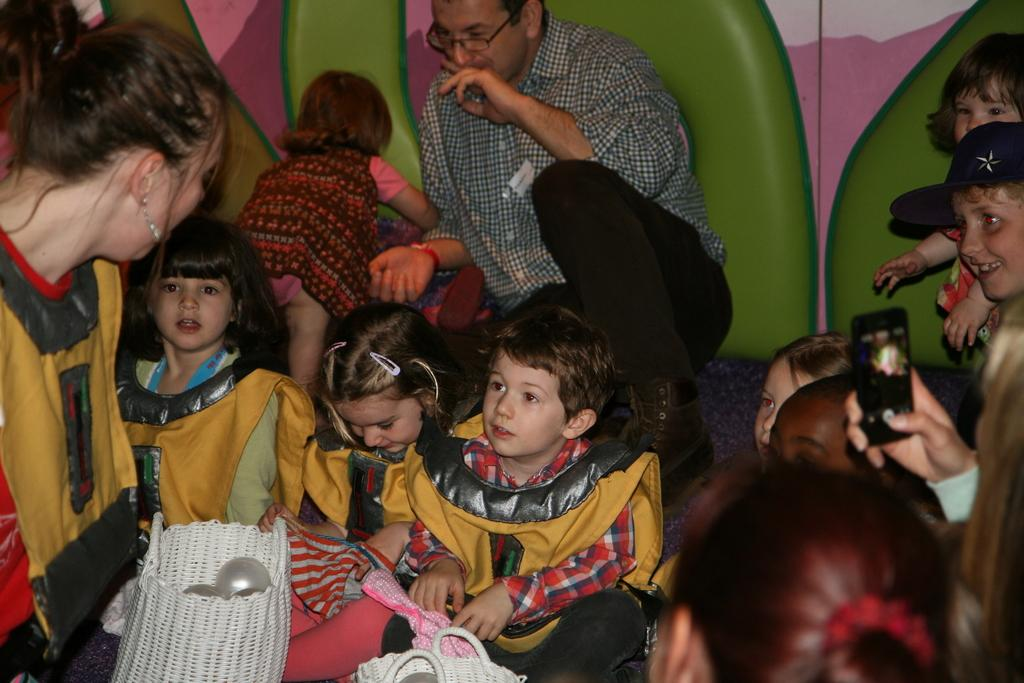What type of individuals can be seen sitting on the surface in the image? There are children and people sitting on the surface in the image. What might the people be doing while sitting on the surface? It is not clear from the image what the people are doing, but they could be engaged in conversation or simply relaxing. Can you describe the person holding an object in their hand? Yes, a person is holding a mobile phone in their hand. What color is the square tongue of the person holding the mobile phone in the image? There is no square tongue present in the image, as people do not have tongues shaped like squares. 